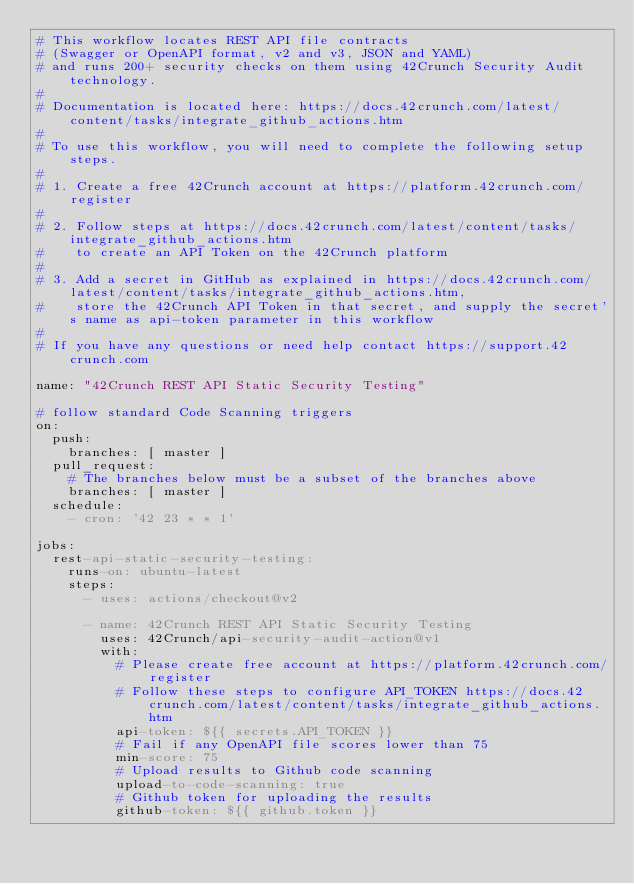Convert code to text. <code><loc_0><loc_0><loc_500><loc_500><_YAML_># This workflow locates REST API file contracts
# (Swagger or OpenAPI format, v2 and v3, JSON and YAML)
# and runs 200+ security checks on them using 42Crunch Security Audit technology.
#
# Documentation is located here: https://docs.42crunch.com/latest/content/tasks/integrate_github_actions.htm
#
# To use this workflow, you will need to complete the following setup steps.
#
# 1. Create a free 42Crunch account at https://platform.42crunch.com/register
#
# 2. Follow steps at https://docs.42crunch.com/latest/content/tasks/integrate_github_actions.htm
#    to create an API Token on the 42Crunch platform
#
# 3. Add a secret in GitHub as explained in https://docs.42crunch.com/latest/content/tasks/integrate_github_actions.htm,
#    store the 42Crunch API Token in that secret, and supply the secret's name as api-token parameter in this workflow
#
# If you have any questions or need help contact https://support.42crunch.com

name: "42Crunch REST API Static Security Testing"

# follow standard Code Scanning triggers
on:
  push:
    branches: [ master ]
  pull_request:
    # The branches below must be a subset of the branches above
    branches: [ master ]
  schedule:
    - cron: '42 23 * * 1'

jobs:
  rest-api-static-security-testing:
    runs-on: ubuntu-latest
    steps:
      - uses: actions/checkout@v2

      - name: 42Crunch REST API Static Security Testing
        uses: 42Crunch/api-security-audit-action@v1
        with:
          # Please create free account at https://platform.42crunch.com/register
          # Follow these steps to configure API_TOKEN https://docs.42crunch.com/latest/content/tasks/integrate_github_actions.htm
          api-token: ${{ secrets.API_TOKEN }}
          # Fail if any OpenAPI file scores lower than 75
          min-score: 75
          # Upload results to Github code scanning
          upload-to-code-scanning: true
          # Github token for uploading the results
          github-token: ${{ github.token }}
</code> 